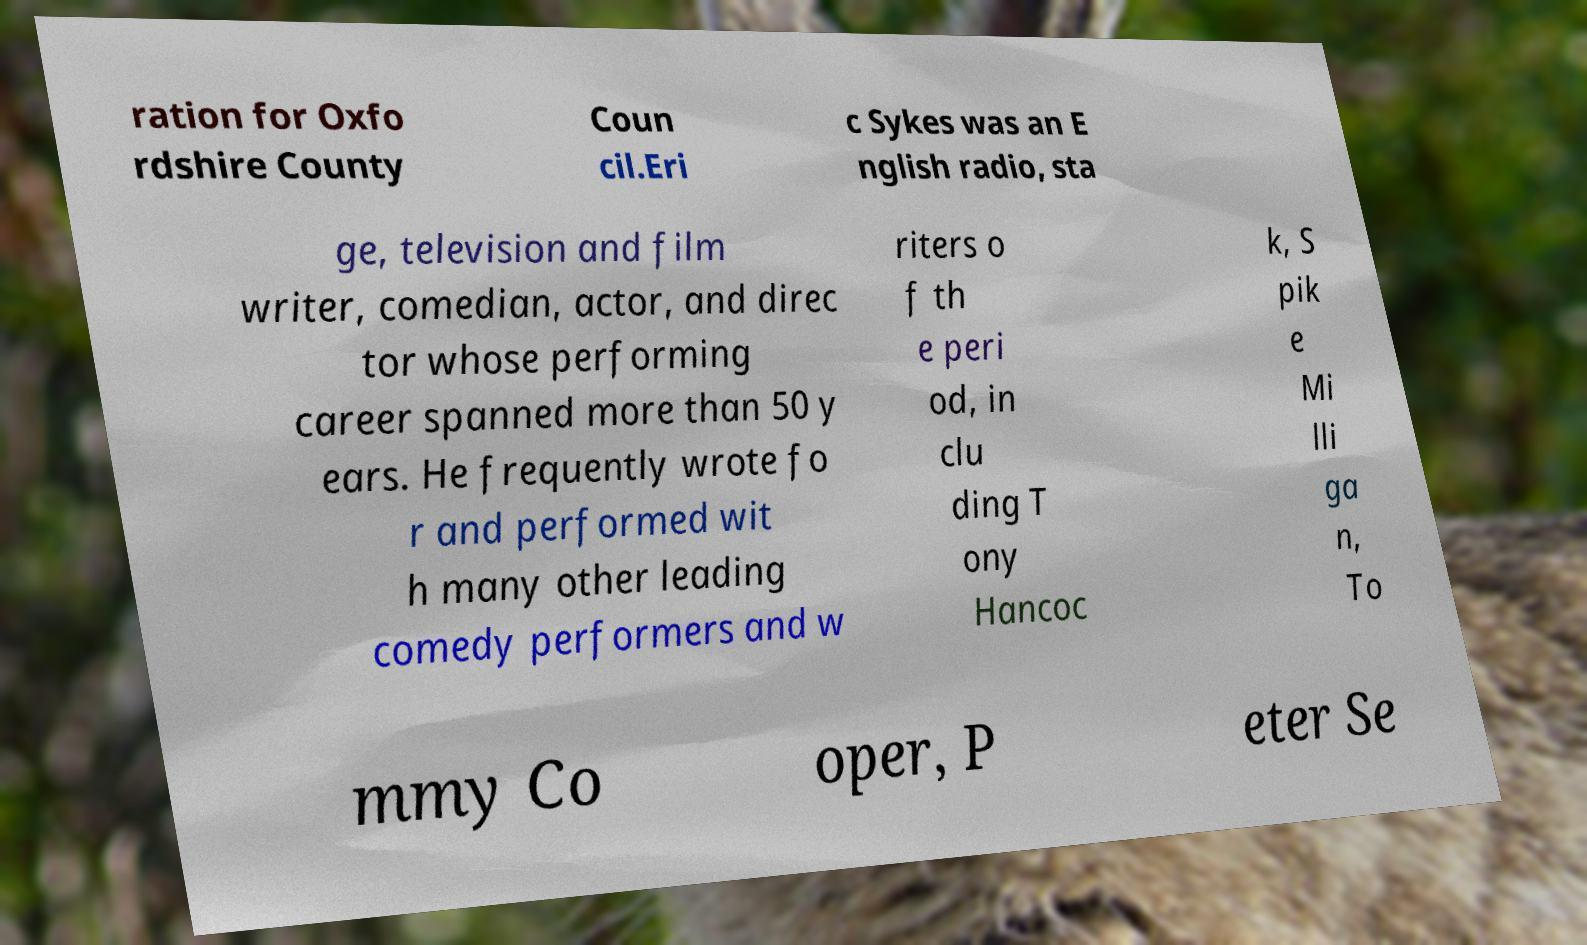Could you assist in decoding the text presented in this image and type it out clearly? ration for Oxfo rdshire County Coun cil.Eri c Sykes was an E nglish radio, sta ge, television and film writer, comedian, actor, and direc tor whose performing career spanned more than 50 y ears. He frequently wrote fo r and performed wit h many other leading comedy performers and w riters o f th e peri od, in clu ding T ony Hancoc k, S pik e Mi lli ga n, To mmy Co oper, P eter Se 